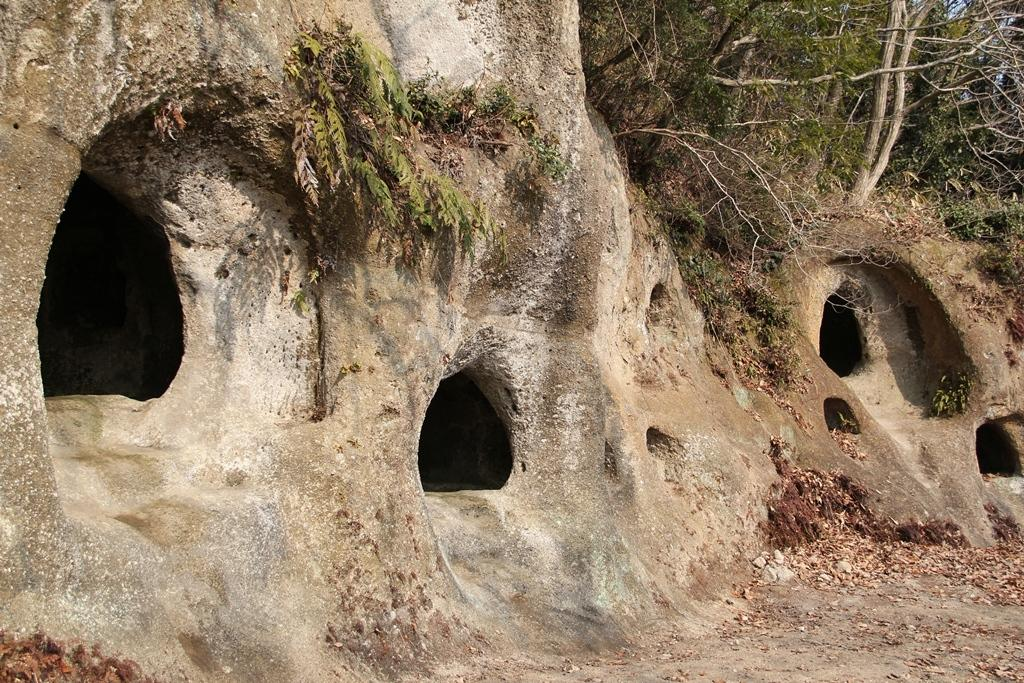What type of vegetation can be seen in the image? There are trees in the image. What is the color of the trees? The trees are green in color. What can be observed on the ground in the image? There are leaves on the ground. What is visible in the background of the image? The sky is visible in the background of the image. How many boats are visible in the image? There are no boats present in the image. What type of mice can be seen interacting with the trees in the image? There are no mice present in the image; it only features trees and leaves on the ground. 